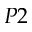<formula> <loc_0><loc_0><loc_500><loc_500>P 2</formula> 